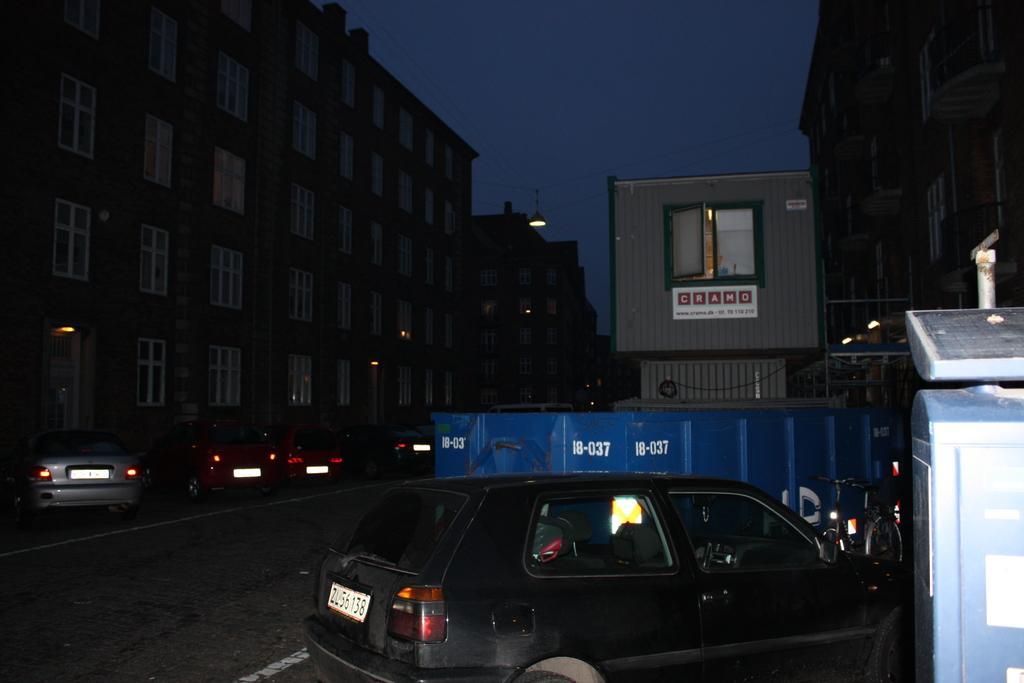Describe this image in one or two sentences. In this image we can see a few cars parked on the road, in the background of the image there are buildings. 